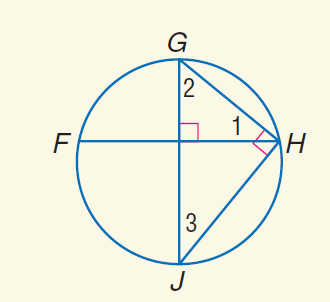Answer the mathemtical geometry problem and directly provide the correct option letter.
Question: m \widehat J H = 114. Find m \angle 2.
Choices: A: 23 B: 33 C: 57 D: 114 C 